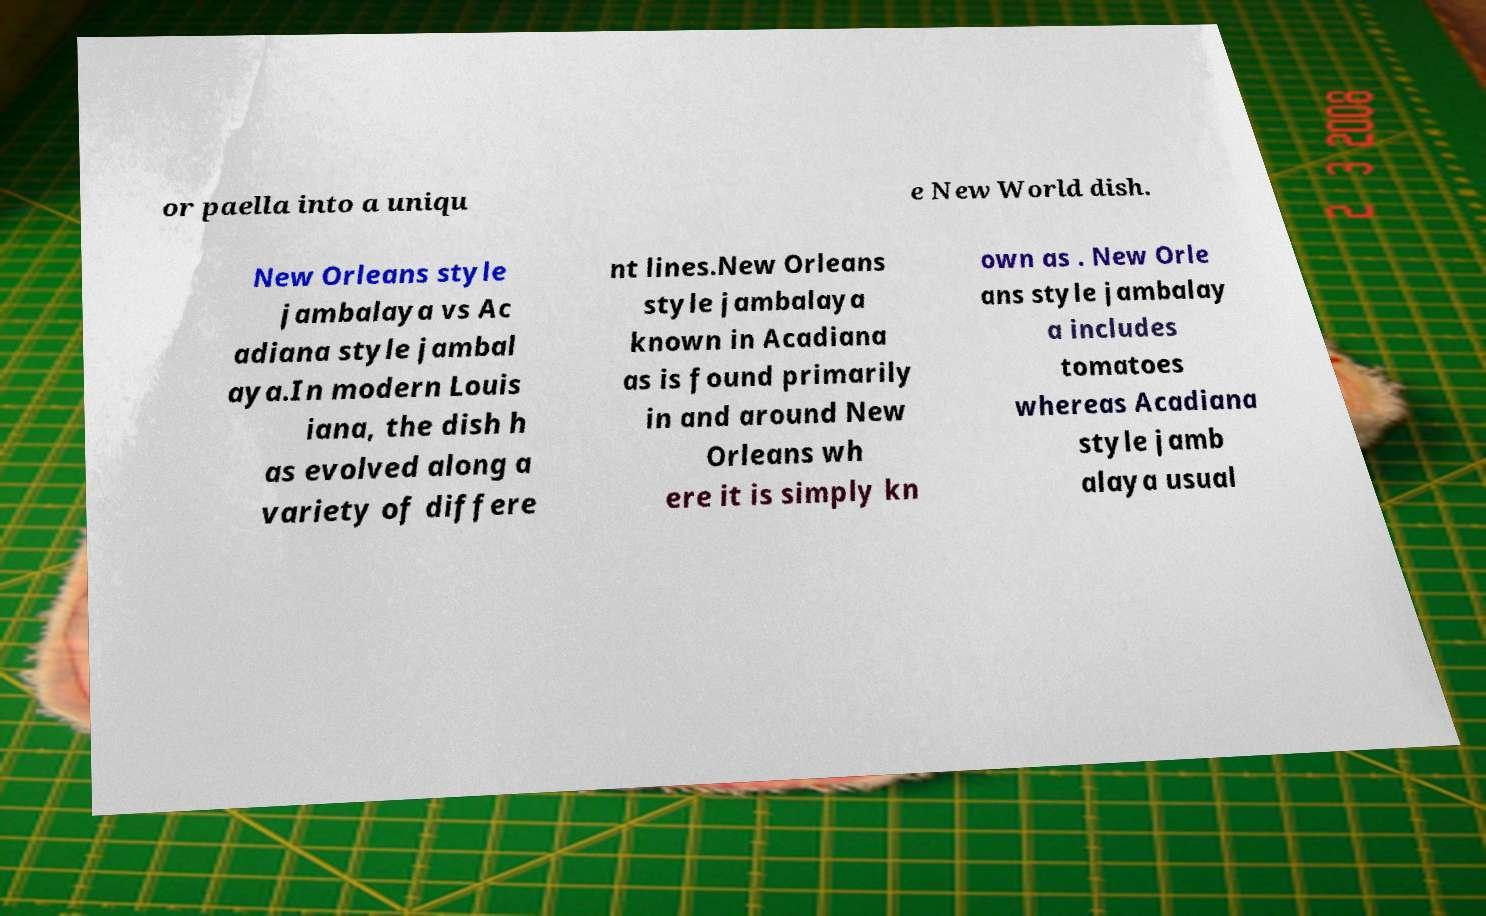There's text embedded in this image that I need extracted. Can you transcribe it verbatim? or paella into a uniqu e New World dish. New Orleans style jambalaya vs Ac adiana style jambal aya.In modern Louis iana, the dish h as evolved along a variety of differe nt lines.New Orleans style jambalaya known in Acadiana as is found primarily in and around New Orleans wh ere it is simply kn own as . New Orle ans style jambalay a includes tomatoes whereas Acadiana style jamb alaya usual 